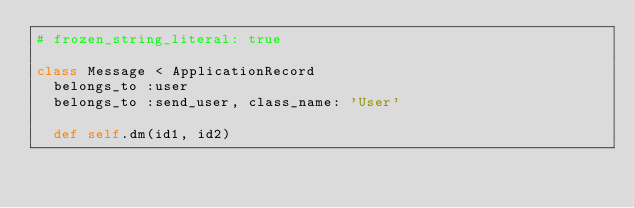Convert code to text. <code><loc_0><loc_0><loc_500><loc_500><_Ruby_># frozen_string_literal: true

class Message < ApplicationRecord
  belongs_to :user
  belongs_to :send_user, class_name: 'User'

  def self.dm(id1, id2)</code> 